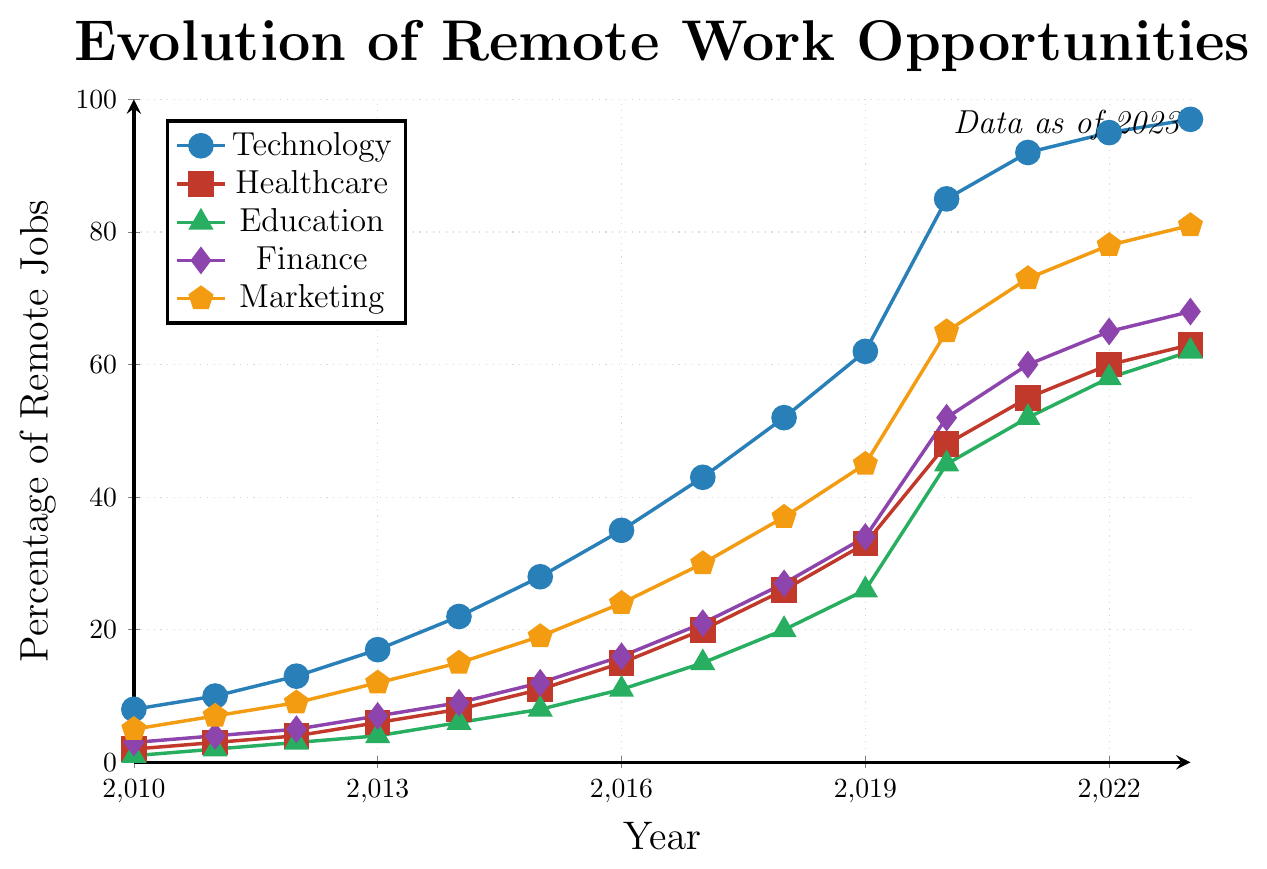How has the percentage of remote jobs in Technology changed from 2010 to 2023? To find the change, subtract the percentage in 2010 from the percentage in 2023. The values are 97% in 2023 and 8% in 2010, so 97 - 8 = 89.
Answer: 89 Which industry had the highest increase in remote work opportunities between 2010 and 2023? Calculate the increase for each industry by subtracting the 2010 percentage from the 2023 percentage. The increases are: Technology (89), Healthcare (61), Education (61), Finance (65), Marketing (76). Thus, the highest increase is in Technology.
Answer: Technology In which year did Education remote jobs surpass 20%? Look for the first year in the Education data that exceeds 20%. In 2018, Education remote jobs are at 20%. The next year, 2019, shows 26%, which surpasses 20%.
Answer: 2019 Compare the percentages of remote jobs in Finance and Marketing in 2020. Which is higher? Check the percentages in 2020: Finance has 52% and Marketing has 65%. So, Marketing is higher.
Answer: Marketing What is the percentage increase in Healthcare remote jobs from 2015 to 2020? Subtract the 2015 value from the 2020 value: 48 - 11 = 37.
Answer: 37 How did the percentage of remote jobs in Marketing change from 2010 to 2015? Subtract the percentage in 2010 from the percentage in 2015. The values are 19% in 2015 and 5% in 2010, so 19 - 5 = 14.
Answer: 14 Which industry had the smallest percentage of remote jobs in 2013? Compare the values for each industry in 2013: Technology (17), Healthcare (6), Education (4), Finance (7), Marketing (12). So, Education had the smallest percentage with 4%.
Answer: Education What was the percentage of remote jobs in Finance in 2022? Look at the Finance data for 2022. The value is 65%.
Answer: 65 How did the remote job opportunities grow in Marketing from 2016 to 2018? The percentage in Marketing in 2016 was 24% and in 2018 it was 37%. Subtract 24 from 37: 37 - 24 = 13.
Answer: 13 Which industry had the highest percentage of remote jobs in 2021? Look at the percentages for all industries in 2021: Technology (92), Healthcare (55), Education (52), Finance (60), Marketing (73). Technology had the highest percentage with 92%.
Answer: Technology 